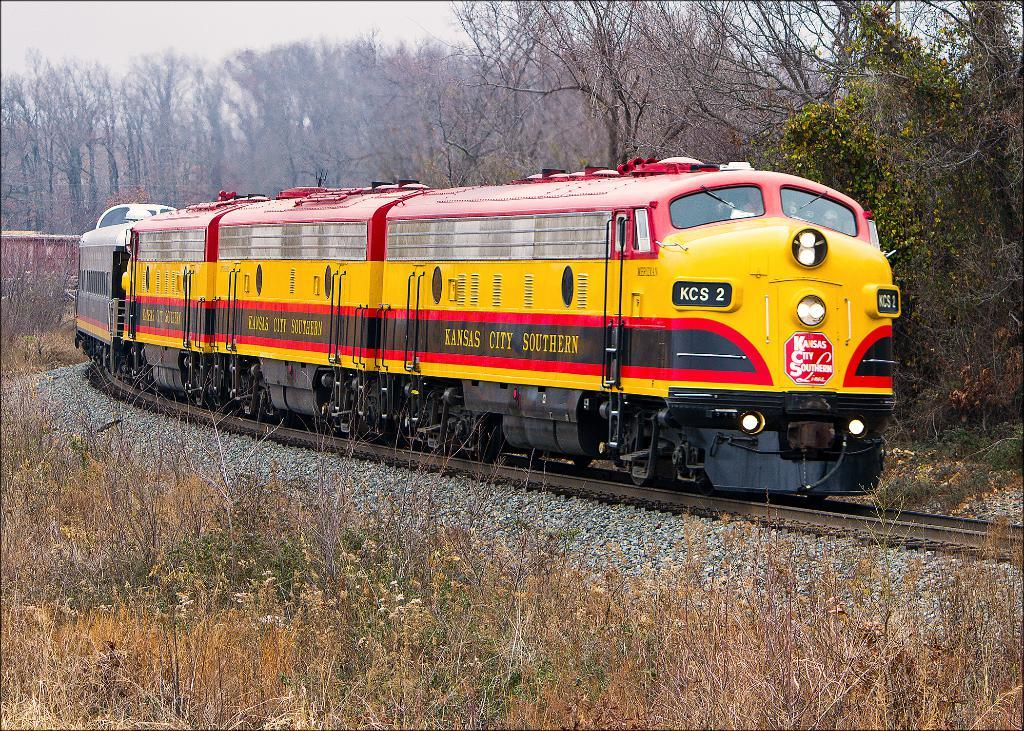What is the main subject of the image? The main subject of the image is a train. Where is the train located? The train is on a railway track. What can be seen on the train? There is writing on the train. What is visible near the railway track? There are stones and grass near the railway track. What can be seen in the background of the image? There are trees in the background of the image. What type of stew is being served in the train's dining car in the image? There is no dining car or stew visible in the image; it only shows a train on a railway track with writing on it. Can you tell me the name of the zebra standing near the train in the image? There is no zebra present in the image; it only shows a train on a railway track with writing on it. 